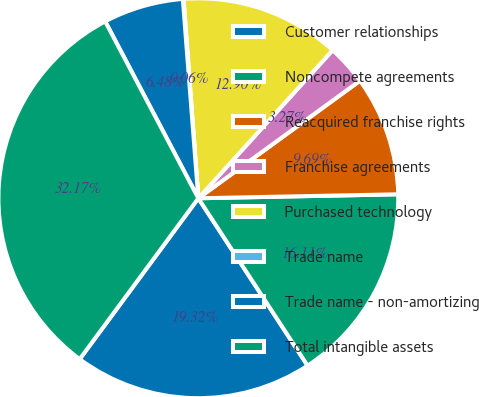Convert chart. <chart><loc_0><loc_0><loc_500><loc_500><pie_chart><fcel>Customer relationships<fcel>Noncompete agreements<fcel>Reacquired franchise rights<fcel>Franchise agreements<fcel>Purchased technology<fcel>Trade name<fcel>Trade name - non-amortizing<fcel>Total intangible assets<nl><fcel>19.32%<fcel>16.11%<fcel>9.69%<fcel>3.27%<fcel>12.9%<fcel>0.06%<fcel>6.48%<fcel>32.17%<nl></chart> 